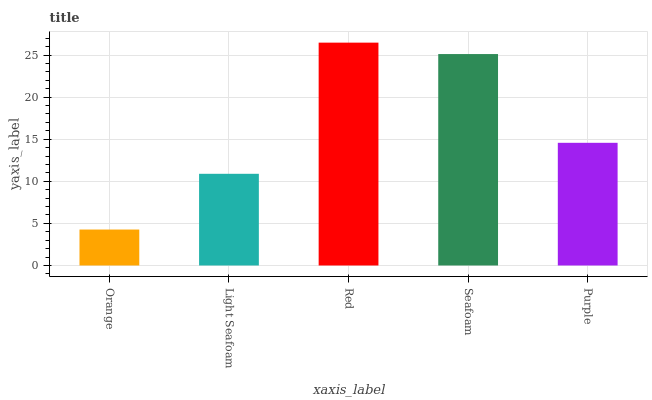Is Light Seafoam the minimum?
Answer yes or no. No. Is Light Seafoam the maximum?
Answer yes or no. No. Is Light Seafoam greater than Orange?
Answer yes or no. Yes. Is Orange less than Light Seafoam?
Answer yes or no. Yes. Is Orange greater than Light Seafoam?
Answer yes or no. No. Is Light Seafoam less than Orange?
Answer yes or no. No. Is Purple the high median?
Answer yes or no. Yes. Is Purple the low median?
Answer yes or no. Yes. Is Light Seafoam the high median?
Answer yes or no. No. Is Red the low median?
Answer yes or no. No. 